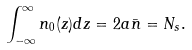Convert formula to latex. <formula><loc_0><loc_0><loc_500><loc_500>\int _ { - \infty } ^ { \infty } n _ { 0 } ( z ) d z = 2 a \bar { n } = N _ { s } .</formula> 